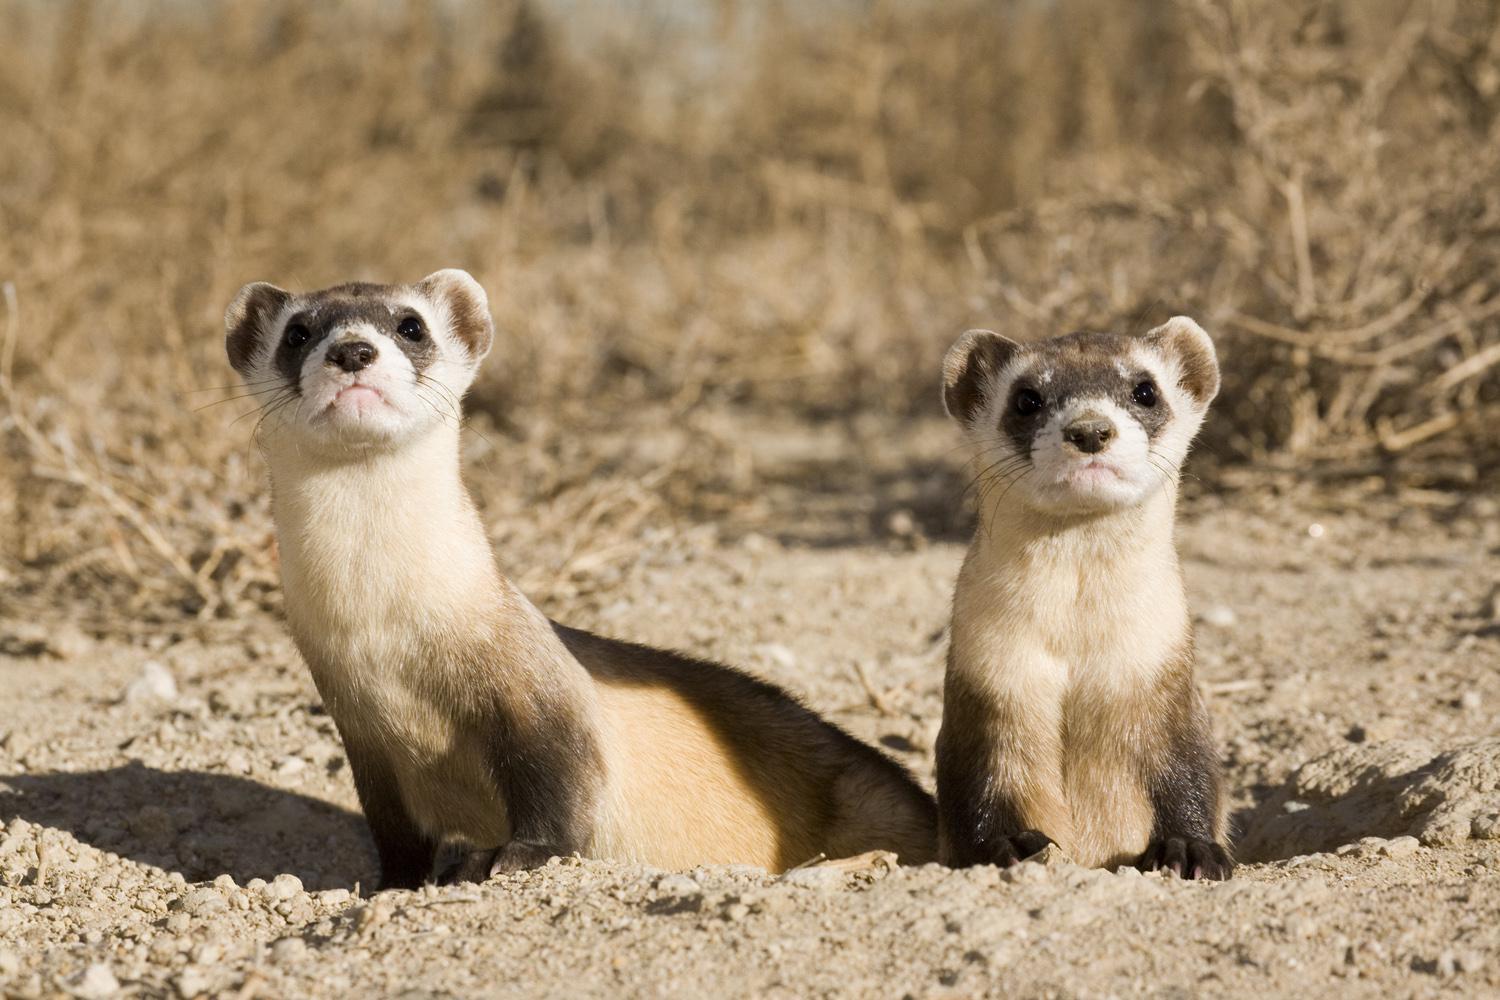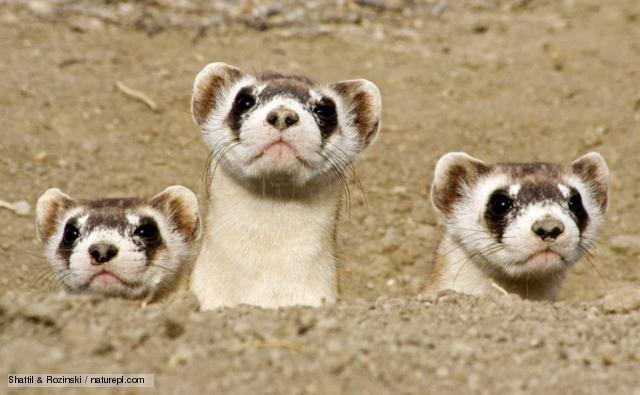The first image is the image on the left, the second image is the image on the right. Considering the images on both sides, is "Exactly one image shows exactly three ferrets poking their heads up above the ground." valid? Answer yes or no. Yes. The first image is the image on the left, the second image is the image on the right. Analyze the images presented: Is the assertion "There are more than five prairie dogs poking up from the ground." valid? Answer yes or no. No. 